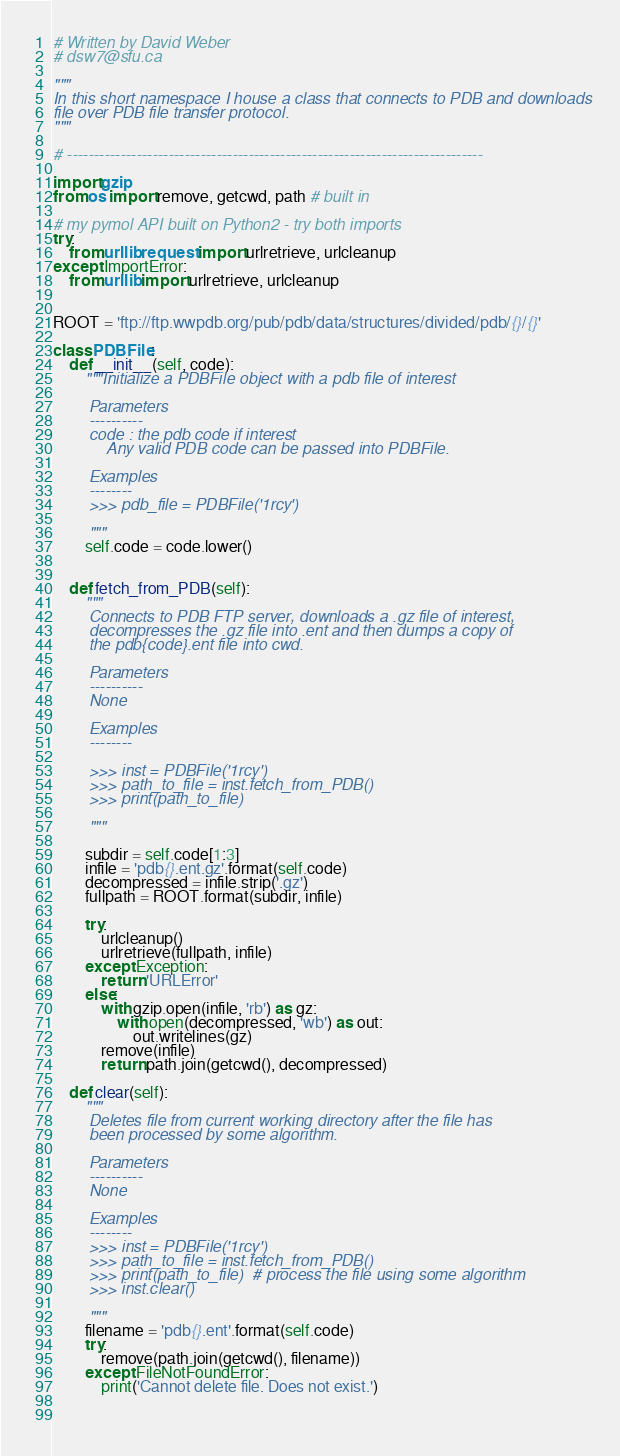<code> <loc_0><loc_0><loc_500><loc_500><_Python_># Written by David Weber
# dsw7@sfu.ca

"""
In this short namespace I house a class that connects to PDB and downloads
file over PDB file transfer protocol.
"""

# ------------------------------------------------------------------------------

import gzip
from os import remove, getcwd, path # built in

# my pymol API built on Python2 - try both imports
try:
    from urllib.request import urlretrieve, urlcleanup
except ImportError:
    from urllib import urlretrieve, urlcleanup 


ROOT = 'ftp://ftp.wwpdb.org/pub/pdb/data/structures/divided/pdb/{}/{}'

class PDBFile:
    def __init__(self, code):
        """Initialize a PDBFile object with a pdb file of interest

        Parameters
        ----------
        code : the pdb code if interest
            Any valid PDB code can be passed into PDBFile.

        Examples
        --------
        >>> pdb_file = PDBFile('1rcy')  
        
        """
        self.code = code.lower()
                                                                

    def fetch_from_PDB(self):
        """
        Connects to PDB FTP server, downloads a .gz file of interest,
        decompresses the .gz file into .ent and then dumps a copy of
        the pdb{code}.ent file into cwd.

        Parameters
        ----------
        None

        Examples
        --------
        
        >>> inst = PDBFile('1rcy')
        >>> path_to_file = inst.fetch_from_PDB()
        >>> print(path_to_file)
        
        """        
            
        subdir = self.code[1:3]
        infile = 'pdb{}.ent.gz'.format(self.code)
        decompressed = infile.strip('.gz')
        fullpath = ROOT.format(subdir, infile)
        
        try:
            urlcleanup()
            urlretrieve(fullpath, infile)
        except Exception:
            return 'URLError'
        else:
            with gzip.open(infile, 'rb') as gz:
                with open(decompressed, 'wb') as out:
                    out.writelines(gz)
            remove(infile)
            return path.join(getcwd(), decompressed)
        
    def clear(self):
        """
        Deletes file from current working directory after the file has
        been processed by some algorithm.

        Parameters
        ----------
        None

        Examples
        --------
        >>> inst = PDBFile('1rcy')
        >>> path_to_file = inst.fetch_from_PDB()
        >>> print(path_to_file)  # process the file using some algorithm
        >>> inst.clear()
        
        """        
        filename = 'pdb{}.ent'.format(self.code)
        try:
            remove(path.join(getcwd(), filename))
        except FileNotFoundError:
            print('Cannot delete file. Does not exist.')
    
    </code> 